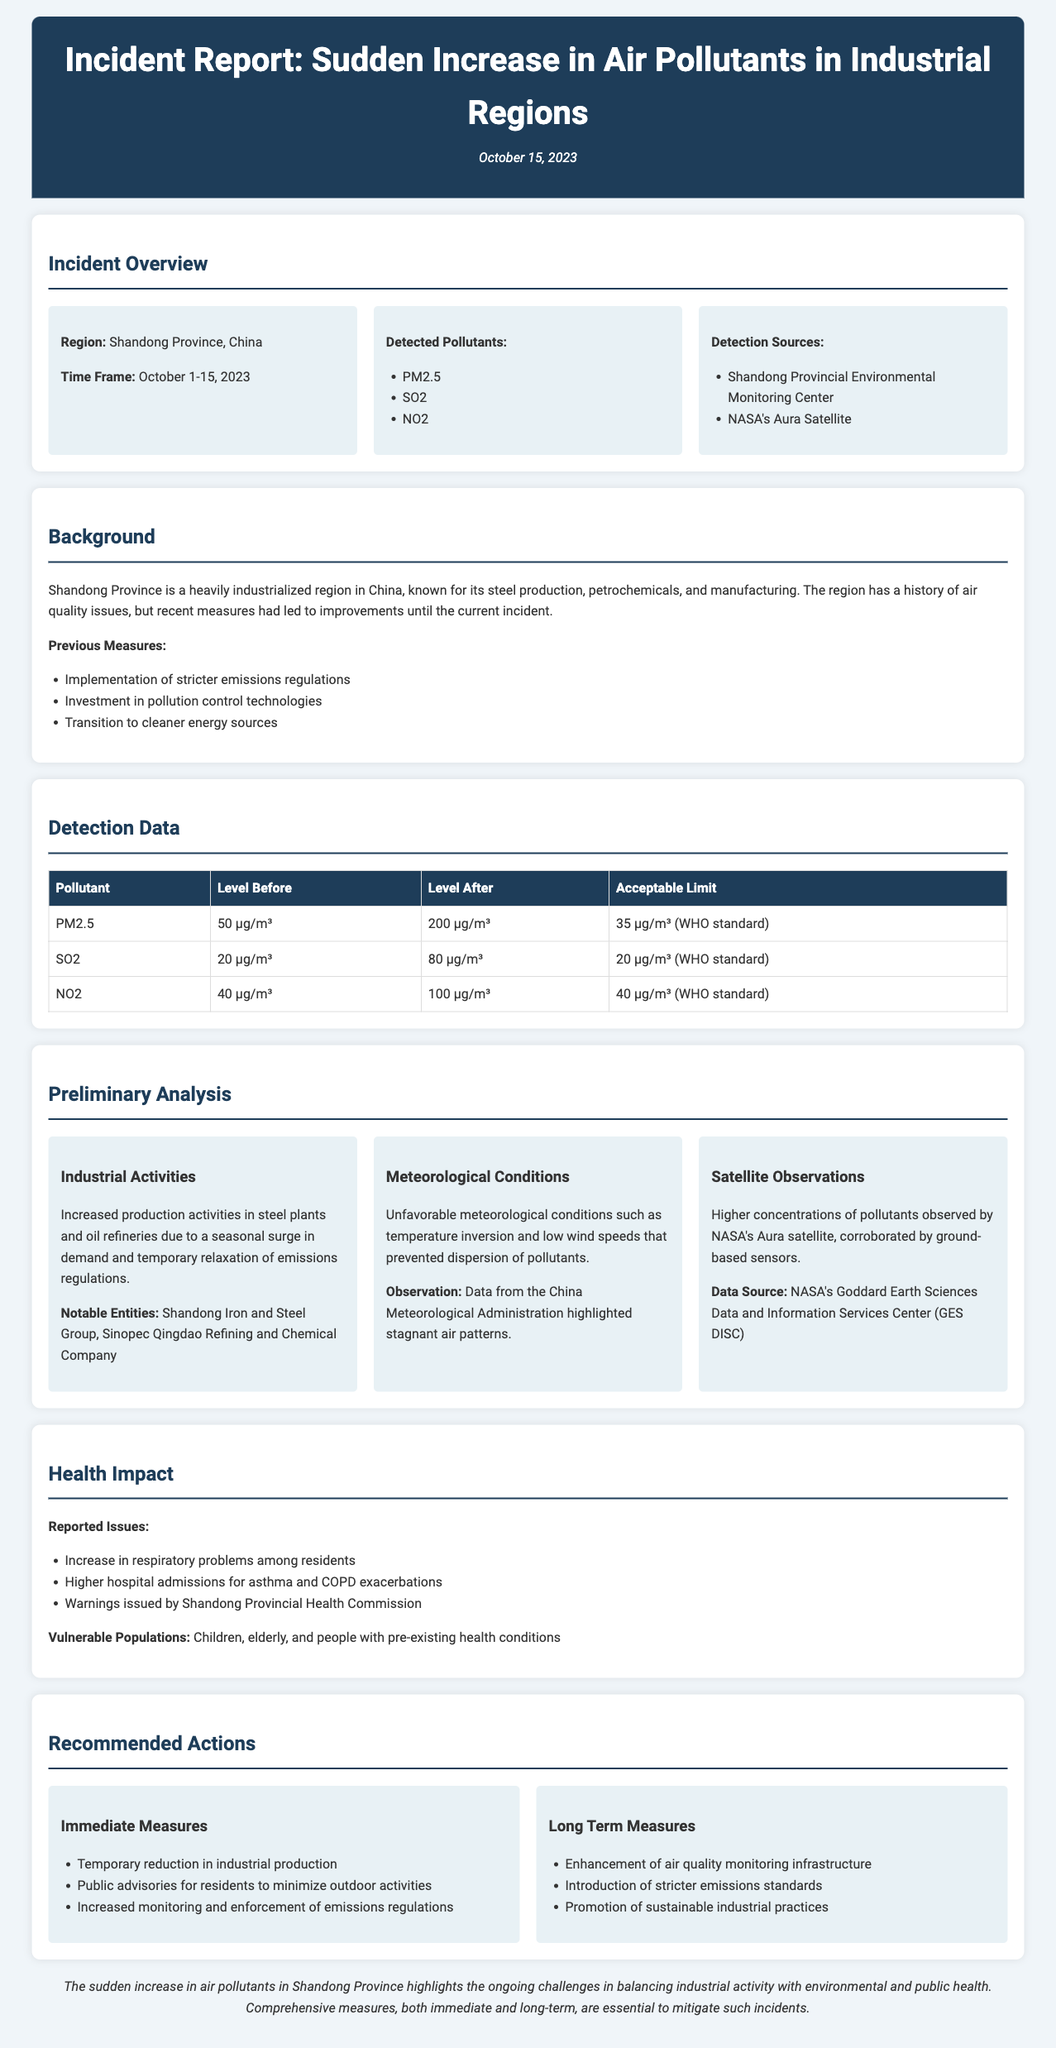What is the region of the incident? The report specifies that the incident occurred in Shandong Province, China.
Answer: Shandong Province, China What were the detected pollutants? The document lists the pollutants detected as PM2.5, SO2, and NO2.
Answer: PM2.5, SO2, NO2 What was the level of PM2.5 before the incident? According to the detection data, the level of PM2.5 before the incident was 50 µg/m³.
Answer: 50 µg/m³ What was a notable entity involved in the incident? The report mentions Shandong Iron and Steel Group as a notable entity associated with industrial activities.
Answer: Shandong Iron and Steel Group What were the immediate recommended measures? The immediate recommended measures include temporary reduction in industrial production and public advisories.
Answer: Temporary reduction in industrial production How did meteorological conditions contribute to the incident? The document states that unfavorable meteorological conditions such as temperature inversion and low wind speeds prevented dispersion of pollutants.
Answer: Temperature inversion and low wind speeds What is the time frame of the incident? The incident report indicates the time frame of the incident as October 1-15, 2023.
Answer: October 1-15, 2023 What were health impact warnings issued for? The documented health impact warnings were given for respiratory problems and increased hospital admissions for asthma and COPD.
Answer: Respiratory problems and increased hospital admissions What are the long-term recommended measures? The long-term measures recommended include enhancement of air quality monitoring infrastructure and stricter emissions standards.
Answer: Enhancement of air quality monitoring infrastructure 